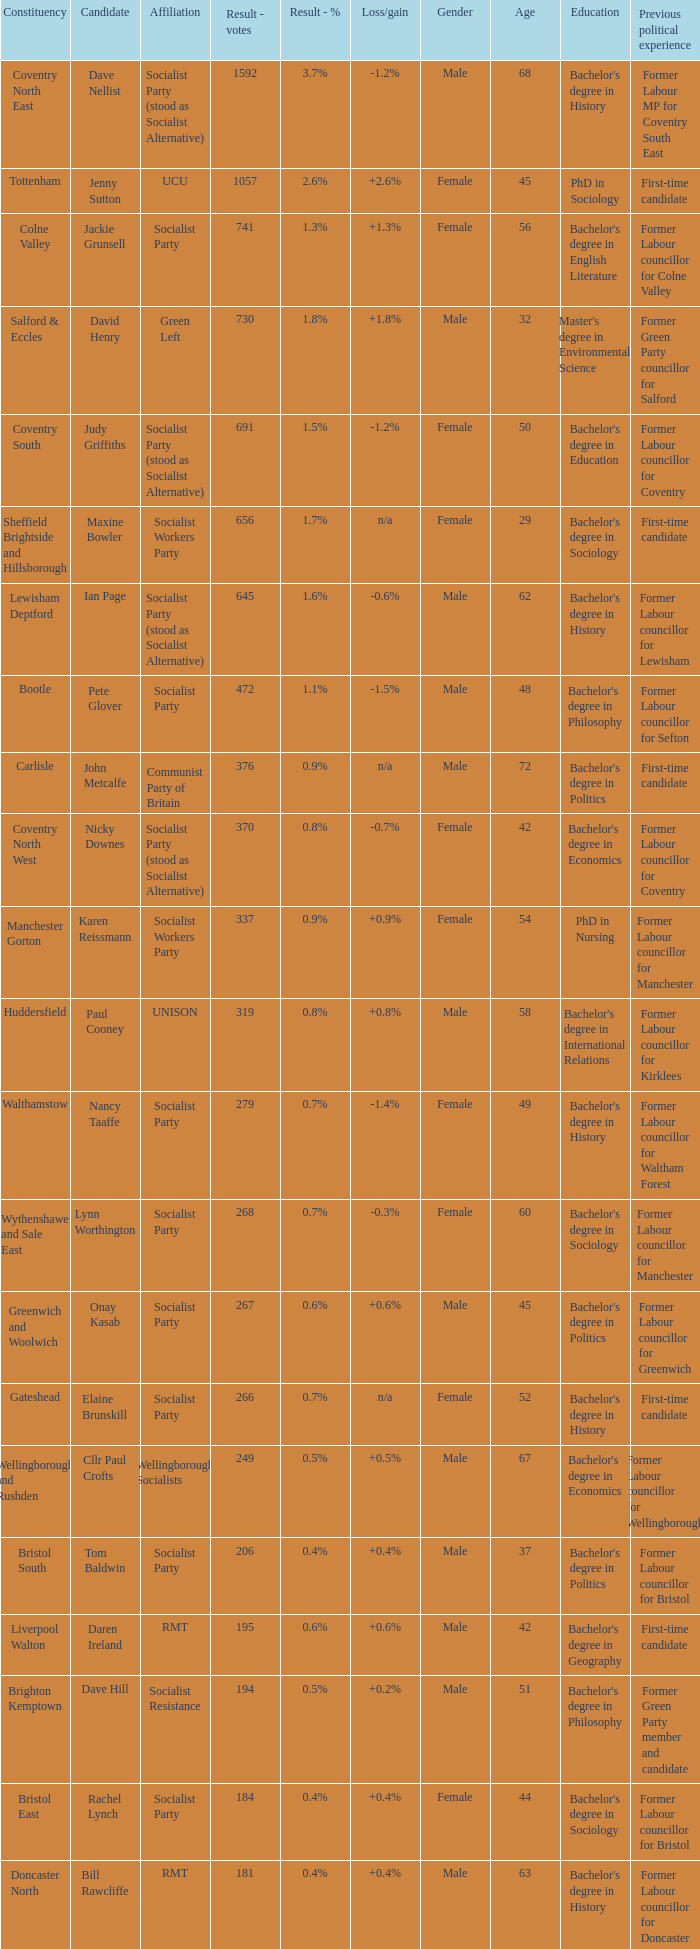Could you parse the entire table? {'header': ['Constituency', 'Candidate', 'Affiliation', 'Result - votes', 'Result - %', 'Loss/gain', 'Gender', 'Age', 'Education', 'Previous political experience'], 'rows': [['Coventry North East', 'Dave Nellist', 'Socialist Party (stood as Socialist Alternative)', '1592', '3.7%', '-1.2%', 'Male', '68', "Bachelor's degree in History", 'Former Labour MP for Coventry South East'], ['Tottenham', 'Jenny Sutton', 'UCU', '1057', '2.6%', '+2.6%', 'Female', '45', 'PhD in Sociology', 'First-time candidate'], ['Colne Valley', 'Jackie Grunsell', 'Socialist Party', '741', '1.3%', '+1.3%', 'Female', '56', "Bachelor's degree in English Literature", 'Former Labour councillor for Colne Valley'], ['Salford & Eccles', 'David Henry', 'Green Left', '730', '1.8%', '+1.8%', 'Male', '32', "Master's degree in Environmental Science", 'Former Green Party councillor for Salford'], ['Coventry South', 'Judy Griffiths', 'Socialist Party (stood as Socialist Alternative)', '691', '1.5%', '-1.2%', 'Female', '50', "Bachelor's degree in Education", 'Former Labour councillor for Coventry'], ['Sheffield Brightside and Hillsborough', 'Maxine Bowler', 'Socialist Workers Party', '656', '1.7%', 'n/a', 'Female', '29', "Bachelor's degree in Sociology", 'First-time candidate'], ['Lewisham Deptford', 'Ian Page', 'Socialist Party (stood as Socialist Alternative)', '645', '1.6%', '-0.6%', 'Male', '62', "Bachelor's degree in History", 'Former Labour councillor for Lewisham'], ['Bootle', 'Pete Glover', 'Socialist Party', '472', '1.1%', '-1.5%', 'Male', '48', "Bachelor's degree in Philosophy", 'Former Labour councillor for Sefton'], ['Carlisle', 'John Metcalfe', 'Communist Party of Britain', '376', '0.9%', 'n/a', 'Male', '72', "Bachelor's degree in Politics", 'First-time candidate'], ['Coventry North West', 'Nicky Downes', 'Socialist Party (stood as Socialist Alternative)', '370', '0.8%', '-0.7%', 'Female', '42', "Bachelor's degree in Economics", 'Former Labour councillor for Coventry'], ['Manchester Gorton', 'Karen Reissmann', 'Socialist Workers Party', '337', '0.9%', '+0.9%', 'Female', '54', 'PhD in Nursing', 'Former Labour councillor for Manchester'], ['Huddersfield', 'Paul Cooney', 'UNISON', '319', '0.8%', '+0.8%', 'Male', '58', "Bachelor's degree in International Relations", 'Former Labour councillor for Kirklees'], ['Walthamstow', 'Nancy Taaffe', 'Socialist Party', '279', '0.7%', '-1.4%', 'Female', '49', "Bachelor's degree in History", 'Former Labour councillor for Waltham Forest'], ['Wythenshawe and Sale East', 'Lynn Worthington', 'Socialist Party', '268', '0.7%', '-0.3%', 'Female', '60', "Bachelor's degree in Sociology", 'Former Labour councillor for Manchester'], ['Greenwich and Woolwich', 'Onay Kasab', 'Socialist Party', '267', '0.6%', '+0.6%', 'Male', '45', "Bachelor's degree in Politics", 'Former Labour councillor for Greenwich'], ['Gateshead', 'Elaine Brunskill', 'Socialist Party', '266', '0.7%', 'n/a', 'Female', '52', "Bachelor's degree in History", 'First-time candidate'], ['Wellingborough and Rushden', 'Cllr Paul Crofts', 'Wellingborough Socialists', '249', '0.5%', '+0.5%', 'Male', '67', "Bachelor's degree in Economics", 'Former Labour councillor for Wellingborough'], ['Bristol South', 'Tom Baldwin', 'Socialist Party', '206', '0.4%', '+0.4%', 'Male', '37', "Bachelor's degree in Politics", 'Former Labour councillor for Bristol'], ['Liverpool Walton', 'Daren Ireland', 'RMT', '195', '0.6%', '+0.6%', 'Male', '42', "Bachelor's degree in Geography", 'First-time candidate'], ['Brighton Kemptown', 'Dave Hill', 'Socialist Resistance', '194', '0.5%', '+0.2%', 'Male', '51', "Bachelor's degree in Philosophy", 'Former Green Party member and candidate'], ['Bristol East', 'Rachel Lynch', 'Socialist Party', '184', '0.4%', '+0.4%', 'Female', '44', "Bachelor's degree in Sociology", 'Former Labour councillor for Bristol'], ['Doncaster North', 'Bill Rawcliffe', 'RMT', '181', '0.4%', '+0.4%', 'Male', '63', "Bachelor's degree in History", 'Former Labour councillor for Doncaster'], ['Swansea West', 'Rob Williams', 'Socialist Party', '179', '0.5%', '-0.4%', 'Male', '56', "Bachelor's degree in History", 'Former Labour councillor for Swansea'], ['Spelthorne', 'Paul Couchman', 'Socialist Party', '176', '0.4%', '+0.4%', 'Male', '39', "Bachelor's degree in Politics", 'First-time candidate'], ['Southampton Itchen', 'Tim Cutter', 'Socialist Party', '168', '0.4%', '+0.4%', 'Male', '35', "Bachelor's degree in Sociology", 'First-time candidate'], ['Cardiff Central', 'Ross Saunders', 'Socialist Party', '162', '0.4%', '+0.4%', 'Male', '28', "Bachelor's degree in Politics", 'Former Labour councillor for Cardiff'], ['Leicester West', 'Steve Score', 'Socialist Party', '157', '0.4%', '-1.3%', 'Male', '60', "Bachelor's degree in Economics", 'Former Labour councillor for Leicester'], ['Portsmouth North', 'Mick Tosh', 'RMT', '154', '0.3%', '+0.3%', 'Male', '49', "Bachelor's degree in Geography", 'First-time candidate'], ['Kingston upon Hull West and Hessle', 'Keith Gibson', 'Socialist Party', '150', '0.5%', '+0.5%', 'Male', '54', "Bachelor's degree in Sociology", 'Former Labour councillor for Hull'], ['Stoke-on-Trent Central', 'Matthew Wright', 'Socialist Party', '133', '0.4%', '-0.5%', 'Male', '43', "Bachelor's degree in Politics", 'Former Labour councillor for Stoke-on-Trent']]} What is every affiliation for the Tottenham constituency? UCU. 